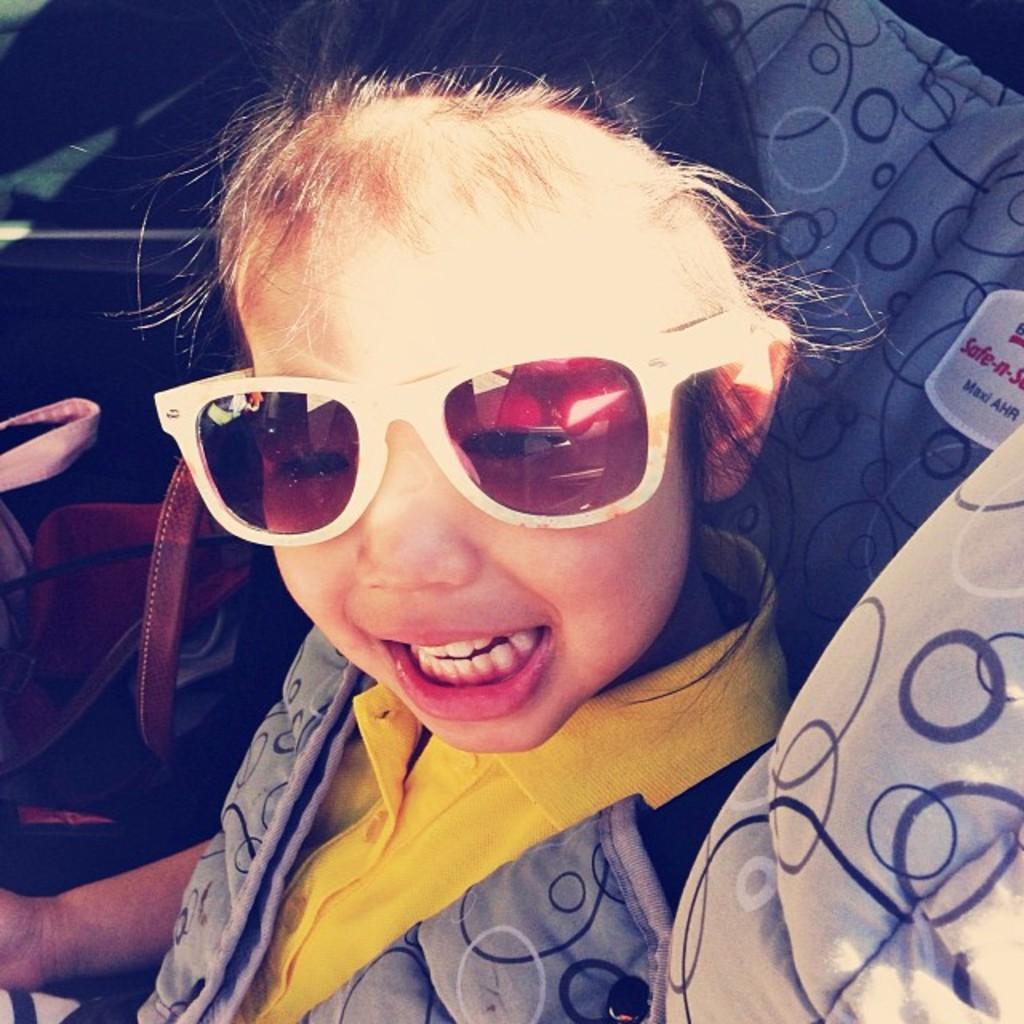Please provide a concise description of this image. This is the picture of a kid who wore spectacles and beside there is a some holder. 